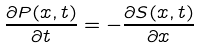Convert formula to latex. <formula><loc_0><loc_0><loc_500><loc_500>\frac { \partial P ( x , t ) } { \partial t } = - \frac { \partial S ( x , t ) } { \partial x }</formula> 